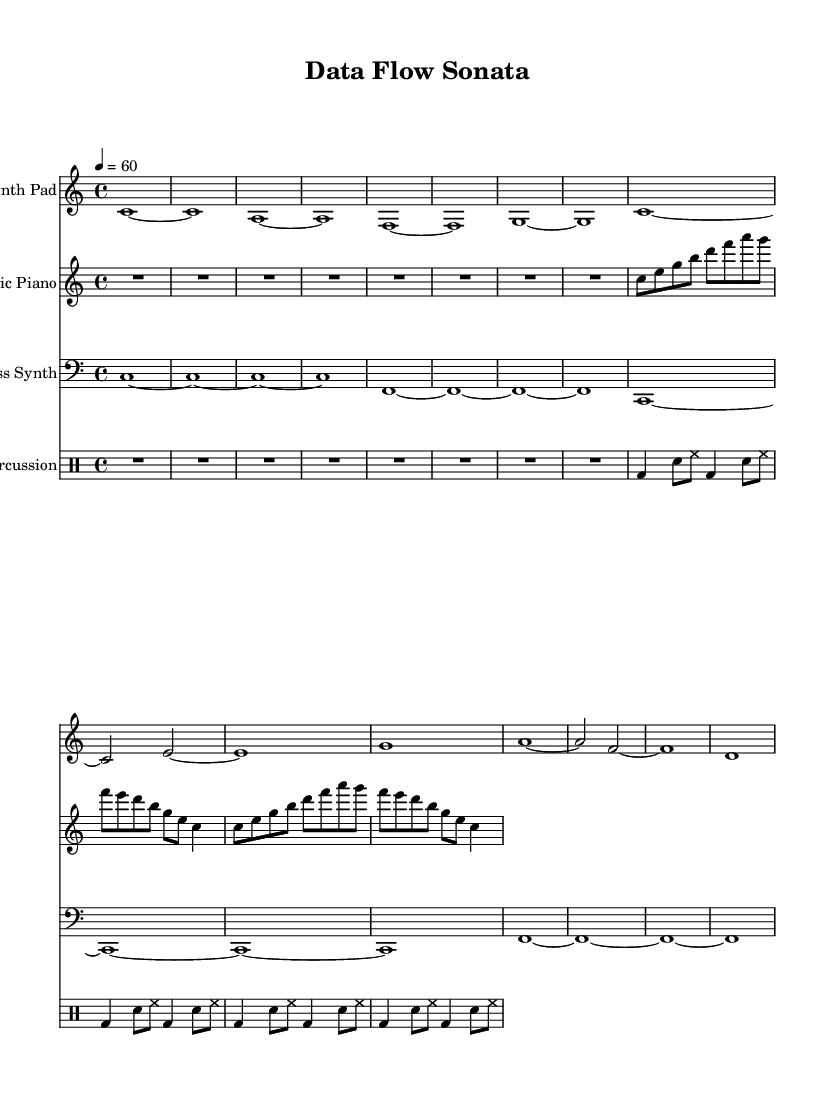What is the key signature of this music? The key signature is indicated at the beginning of the piece, where it shows 'c' with no sharps or flats, which corresponds to the key of C major.
Answer: C major What is the time signature of this music? The time signature is located next to the key signature and shows '4/4', meaning there are four beats in a measure and a quarter note gets one beat.
Answer: 4/4 What is the tempo marking for this music? The tempo marking is present in the initial part of the score, indicating '4 = 60' which means there are 60 beats per minute.
Answer: 60 What instruments are included in this score? The instruments can be identified in the title of each staff within the score; they include Synth Pad, Electric Piano, Bass Synth, and Percussion.
Answer: Synth Pad, Electric Piano, Bass Synth, Percussion How many measures are in the intro section of the music? By counting the groups of notes in the intro section (marked in the synthesizer and percussion parts), there are a total of 8 measures dedicated to the intro.
Answer: 8 Which section contains the main theme of the music? The main theme follows the intro and includes specific note patterns outlined in the synthPad and electricPiano parts, identifiable in the score after the first 8 measures.
Answer: Main Theme Identify the rhythmic pattern used in the percussion section. Analyzing the drummode section, the pattern consists of kick drum (bd), snare (sn), and hi-hat (hh) in a repetitive structure with alternating divisions, maintaining a steady rhythm throughout the main theme.
Answer: Kick, snare, hi-hat 